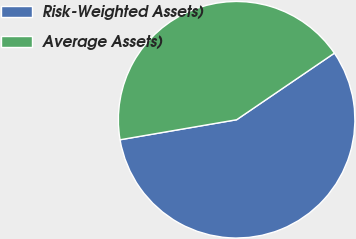Convert chart to OTSL. <chart><loc_0><loc_0><loc_500><loc_500><pie_chart><fcel>Risk-Weighted Assets)<fcel>Average Assets)<nl><fcel>56.81%<fcel>43.19%<nl></chart> 